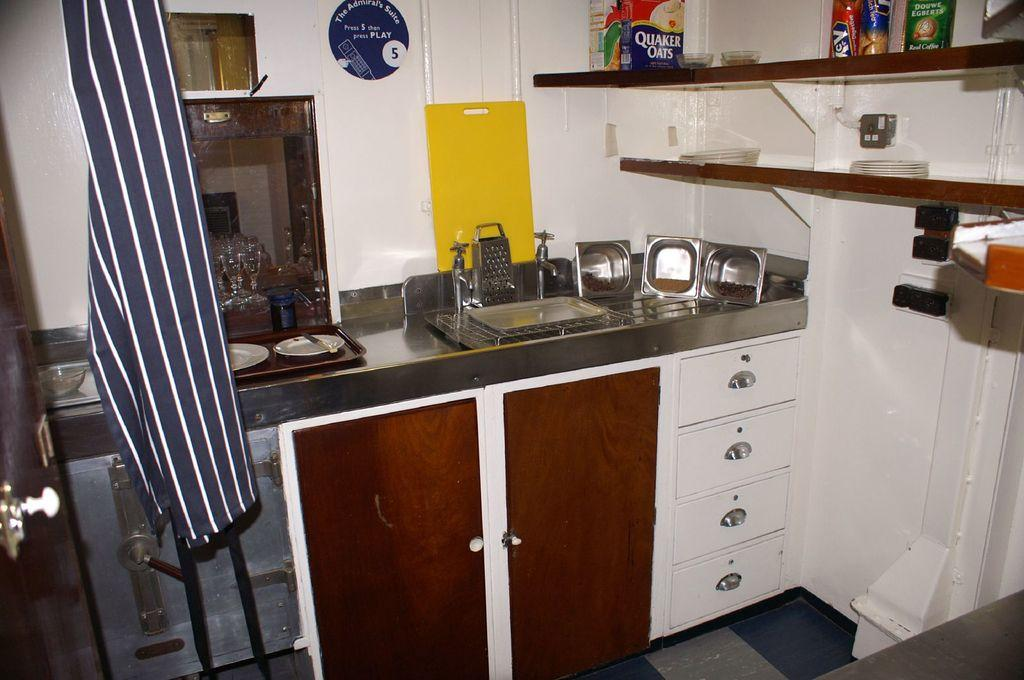Provide a one-sentence caption for the provided image. A box of Quaker Oats sits on the top shelf above the sink. 